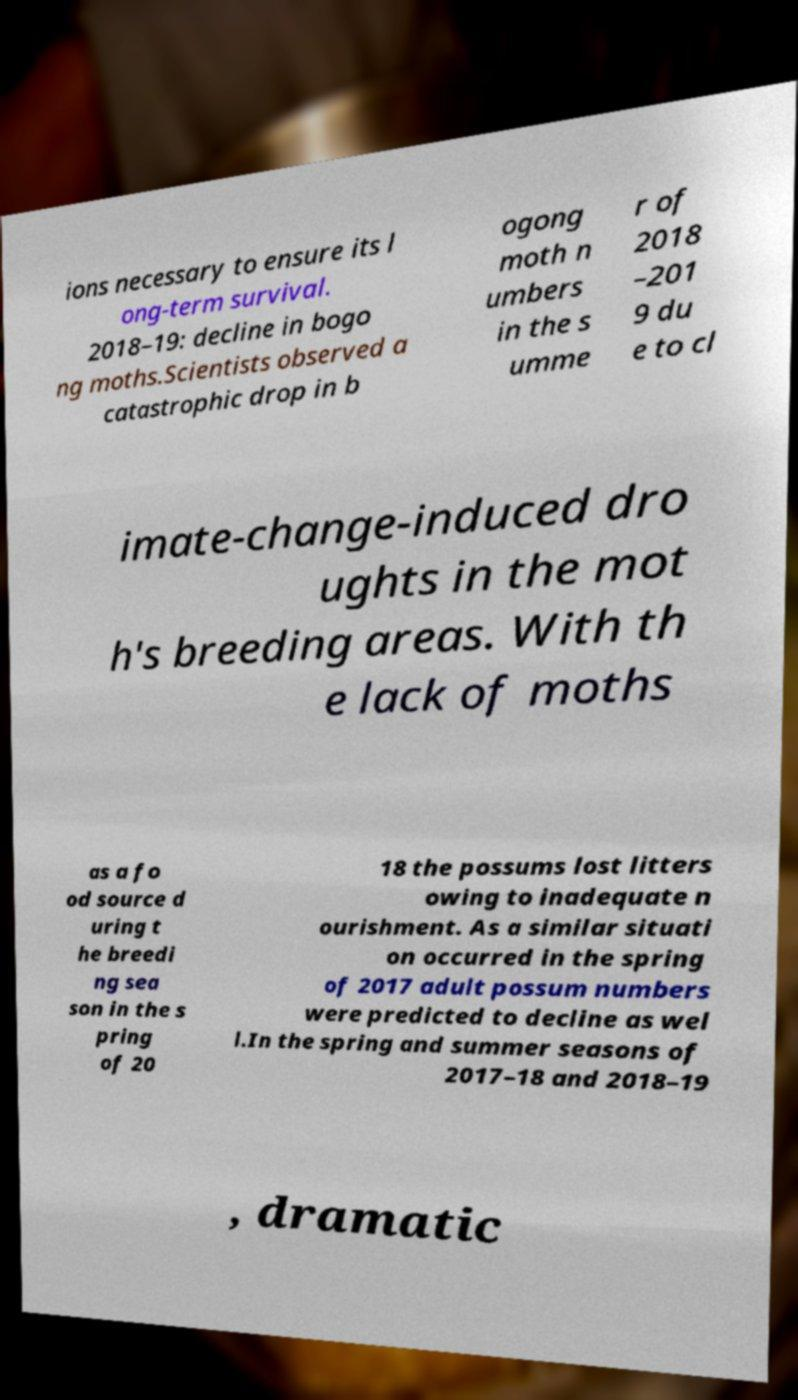Can you read and provide the text displayed in the image?This photo seems to have some interesting text. Can you extract and type it out for me? ions necessary to ensure its l ong-term survival. 2018–19: decline in bogo ng moths.Scientists observed a catastrophic drop in b ogong moth n umbers in the s umme r of 2018 –201 9 du e to cl imate-change-induced dro ughts in the mot h's breeding areas. With th e lack of moths as a fo od source d uring t he breedi ng sea son in the s pring of 20 18 the possums lost litters owing to inadequate n ourishment. As a similar situati on occurred in the spring of 2017 adult possum numbers were predicted to decline as wel l.In the spring and summer seasons of 2017–18 and 2018–19 , dramatic 